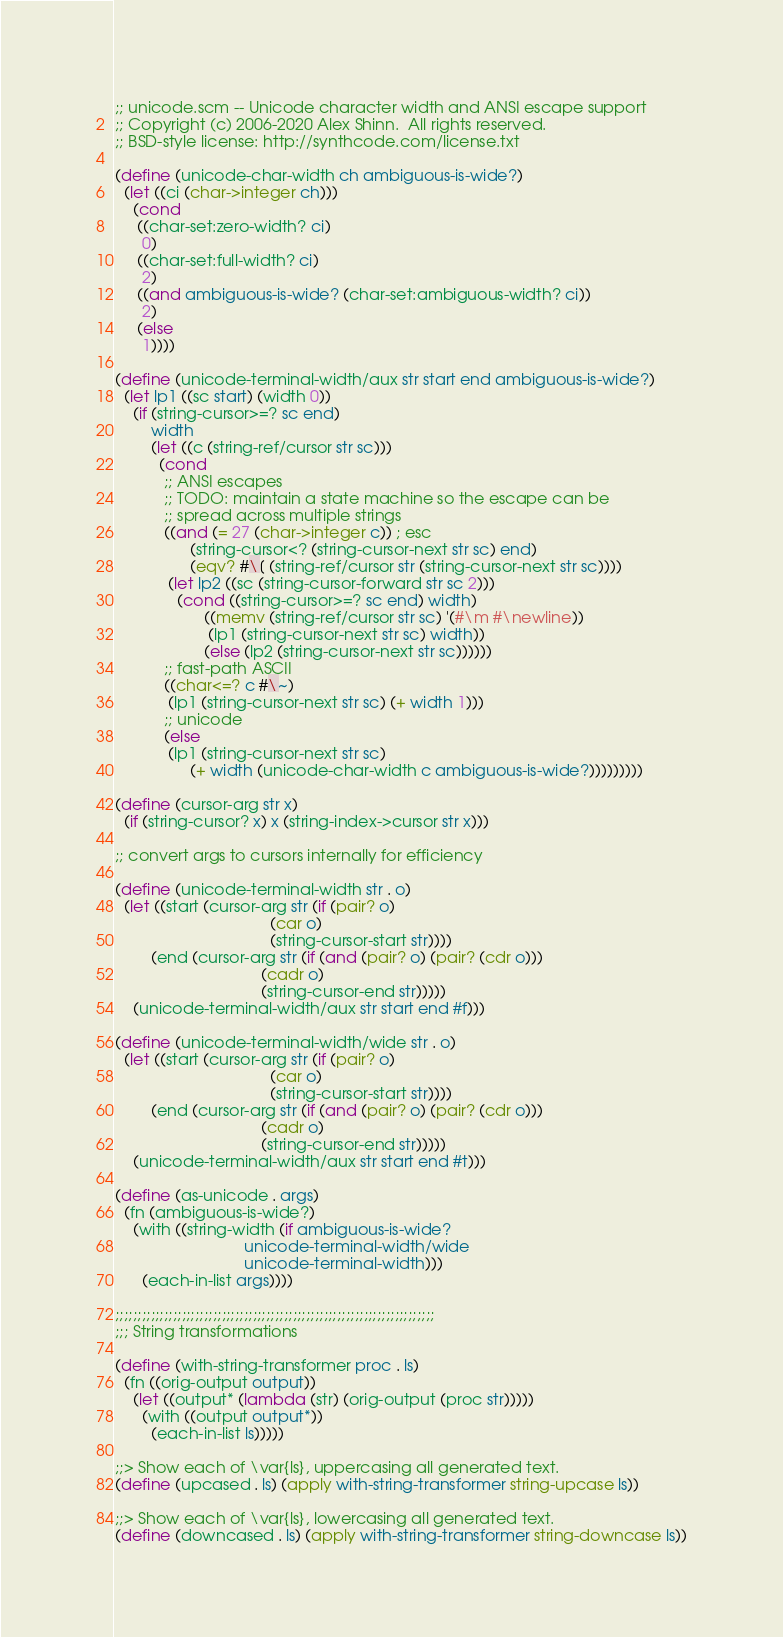<code> <loc_0><loc_0><loc_500><loc_500><_Scheme_>;; unicode.scm -- Unicode character width and ANSI escape support
;; Copyright (c) 2006-2020 Alex Shinn.  All rights reserved.
;; BSD-style license: http://synthcode.com/license.txt

(define (unicode-char-width ch ambiguous-is-wide?)
  (let ((ci (char->integer ch)))
    (cond
     ((char-set:zero-width? ci)
      0)
     ((char-set:full-width? ci)
      2)
     ((and ambiguous-is-wide? (char-set:ambiguous-width? ci))
      2)
     (else
      1))))

(define (unicode-terminal-width/aux str start end ambiguous-is-wide?)
  (let lp1 ((sc start) (width 0))
    (if (string-cursor>=? sc end)
        width
        (let ((c (string-ref/cursor str sc)))
          (cond
           ;; ANSI escapes
           ;; TODO: maintain a state machine so the escape can be
           ;; spread across multiple strings
           ((and (= 27 (char->integer c)) ; esc
                 (string-cursor<? (string-cursor-next str sc) end)
                 (eqv? #\[ (string-ref/cursor str (string-cursor-next str sc))))
            (let lp2 ((sc (string-cursor-forward str sc 2)))
              (cond ((string-cursor>=? sc end) width)
                    ((memv (string-ref/cursor str sc) '(#\m #\newline))
                     (lp1 (string-cursor-next str sc) width))
                    (else (lp2 (string-cursor-next str sc))))))
           ;; fast-path ASCII
           ((char<=? c #\~)
            (lp1 (string-cursor-next str sc) (+ width 1)))
           ;; unicode
           (else
            (lp1 (string-cursor-next str sc)
                 (+ width (unicode-char-width c ambiguous-is-wide?)))))))))

(define (cursor-arg str x)
  (if (string-cursor? x) x (string-index->cursor str x)))

;; convert args to cursors internally for efficiency

(define (unicode-terminal-width str . o)
  (let ((start (cursor-arg str (if (pair? o)
                                   (car o)
                                   (string-cursor-start str))))
        (end (cursor-arg str (if (and (pair? o) (pair? (cdr o)))
                                 (cadr o)
                                 (string-cursor-end str)))))
    (unicode-terminal-width/aux str start end #f)))

(define (unicode-terminal-width/wide str . o)
  (let ((start (cursor-arg str (if (pair? o)
                                   (car o)
                                   (string-cursor-start str))))
        (end (cursor-arg str (if (and (pair? o) (pair? (cdr o)))
                                 (cadr o)
                                 (string-cursor-end str)))))
    (unicode-terminal-width/aux str start end #t)))

(define (as-unicode . args)
  (fn (ambiguous-is-wide?)
    (with ((string-width (if ambiguous-is-wide?
                             unicode-terminal-width/wide
                             unicode-terminal-width)))
      (each-in-list args))))

;;;;;;;;;;;;;;;;;;;;;;;;;;;;;;;;;;;;;;;;;;;;;;;;;;;;;;;;;;;;;;;;;;;;;;;;
;;; String transformations

(define (with-string-transformer proc . ls)
  (fn ((orig-output output))
    (let ((output* (lambda (str) (orig-output (proc str)))))
      (with ((output output*))
        (each-in-list ls)))))

;;> Show each of \var{ls}, uppercasing all generated text.
(define (upcased . ls) (apply with-string-transformer string-upcase ls))

;;> Show each of \var{ls}, lowercasing all generated text.
(define (downcased . ls) (apply with-string-transformer string-downcase ls))
</code> 